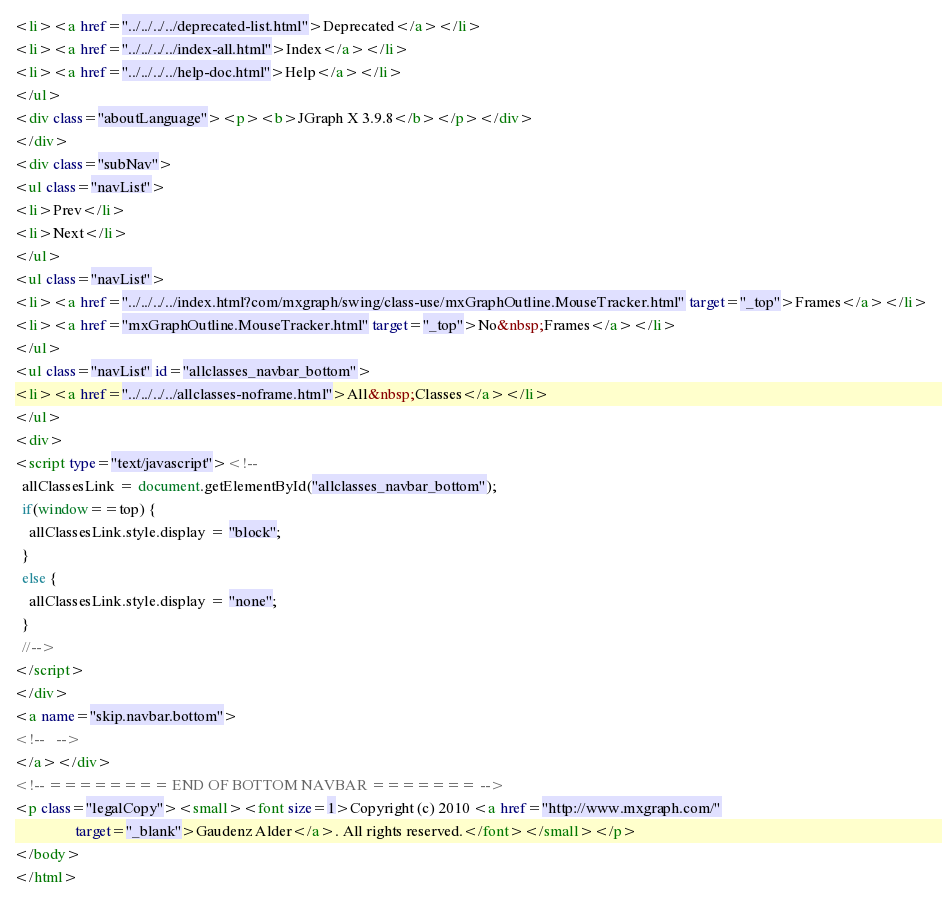<code> <loc_0><loc_0><loc_500><loc_500><_HTML_><li><a href="../../../../deprecated-list.html">Deprecated</a></li>
<li><a href="../../../../index-all.html">Index</a></li>
<li><a href="../../../../help-doc.html">Help</a></li>
</ul>
<div class="aboutLanguage"><p><b>JGraph X 3.9.8</b></p></div>
</div>
<div class="subNav">
<ul class="navList">
<li>Prev</li>
<li>Next</li>
</ul>
<ul class="navList">
<li><a href="../../../../index.html?com/mxgraph/swing/class-use/mxGraphOutline.MouseTracker.html" target="_top">Frames</a></li>
<li><a href="mxGraphOutline.MouseTracker.html" target="_top">No&nbsp;Frames</a></li>
</ul>
<ul class="navList" id="allclasses_navbar_bottom">
<li><a href="../../../../allclasses-noframe.html">All&nbsp;Classes</a></li>
</ul>
<div>
<script type="text/javascript"><!--
  allClassesLink = document.getElementById("allclasses_navbar_bottom");
  if(window==top) {
    allClassesLink.style.display = "block";
  }
  else {
    allClassesLink.style.display = "none";
  }
  //-->
</script>
</div>
<a name="skip.navbar.bottom">
<!--   -->
</a></div>
<!-- ======== END OF BOTTOM NAVBAR ======= -->
<p class="legalCopy"><small><font size=1>Copyright (c) 2010 <a href="http://www.mxgraph.com/"
				target="_blank">Gaudenz Alder</a>. All rights reserved.</font></small></p>
</body>
</html>
</code> 